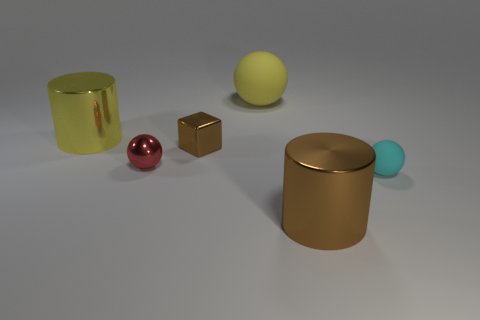Are there any other things that have the same shape as the tiny brown metallic object?
Your response must be concise. No. What shape is the red thing that is behind the metal cylinder that is right of the small shiny cube?
Provide a succinct answer. Sphere. Are there fewer rubber spheres that are in front of the big yellow shiny object than spheres that are on the right side of the small brown thing?
Your answer should be compact. Yes. There is another metallic thing that is the same shape as the big yellow metal thing; what is its size?
Provide a short and direct response. Large. How many things are either large shiny cylinders that are on the left side of the big yellow ball or small brown metallic objects in front of the yellow metallic object?
Keep it short and to the point. 2. Is the yellow cylinder the same size as the cyan rubber object?
Give a very brief answer. No. Is the number of tiny red spheres greater than the number of small green shiny cylinders?
Your answer should be compact. Yes. How many other things are there of the same color as the small shiny cube?
Keep it short and to the point. 1. What number of objects are large metallic objects or matte spheres?
Offer a terse response. 4. There is a big metallic thing on the right side of the big sphere; is it the same shape as the tiny red metal thing?
Provide a succinct answer. No. 